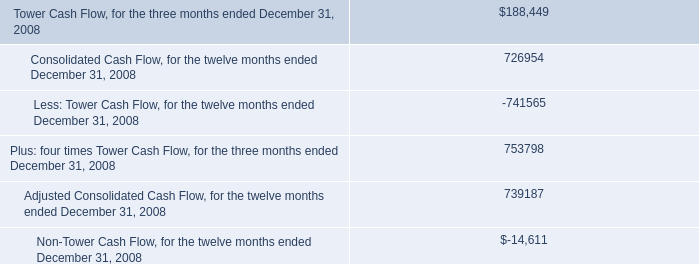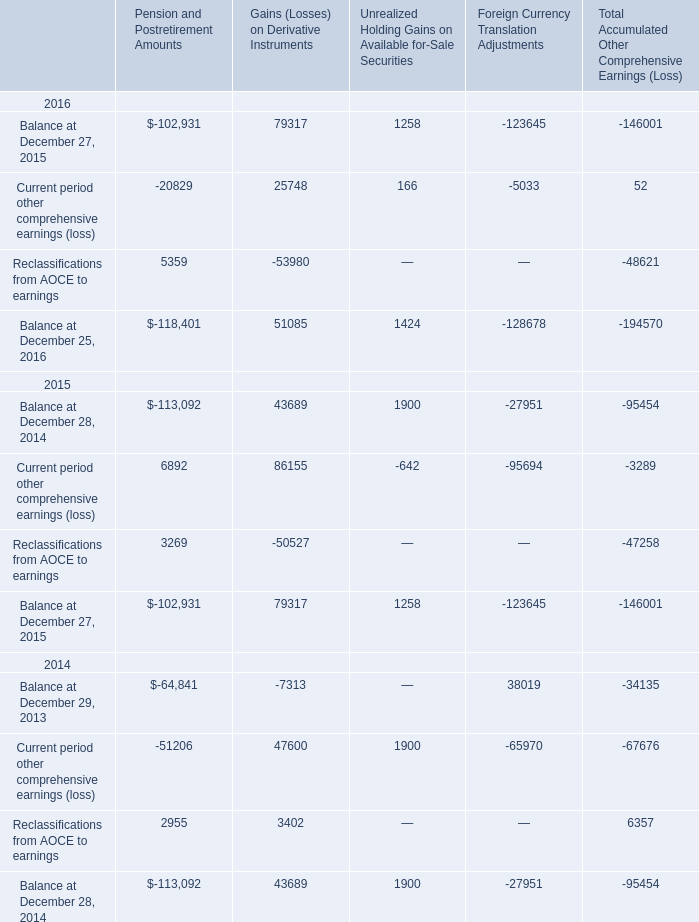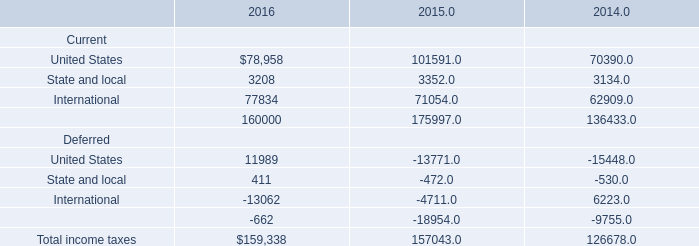What is the average amount of Balance at December 27, 2015 of Pension and Postretirement Amounts, and International Deferred of 2015 ? 
Computations: ((102931.0 + 4711.0) / 2)
Answer: 53821.0. 